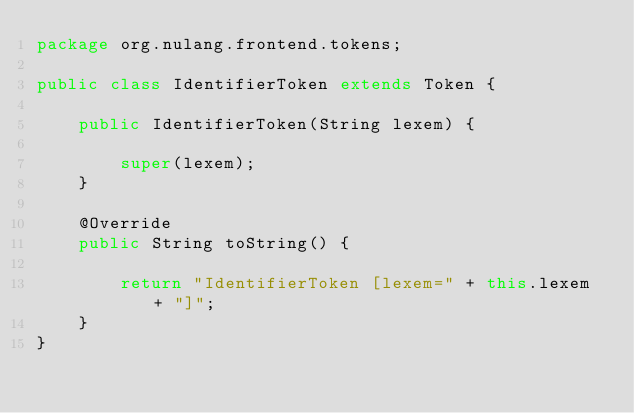Convert code to text. <code><loc_0><loc_0><loc_500><loc_500><_Java_>package org.nulang.frontend.tokens;

public class IdentifierToken extends Token {

	public IdentifierToken(String lexem) {

		super(lexem);
	}

	@Override
	public String toString() {

		return "IdentifierToken [lexem=" + this.lexem + "]";
	}
}
</code> 